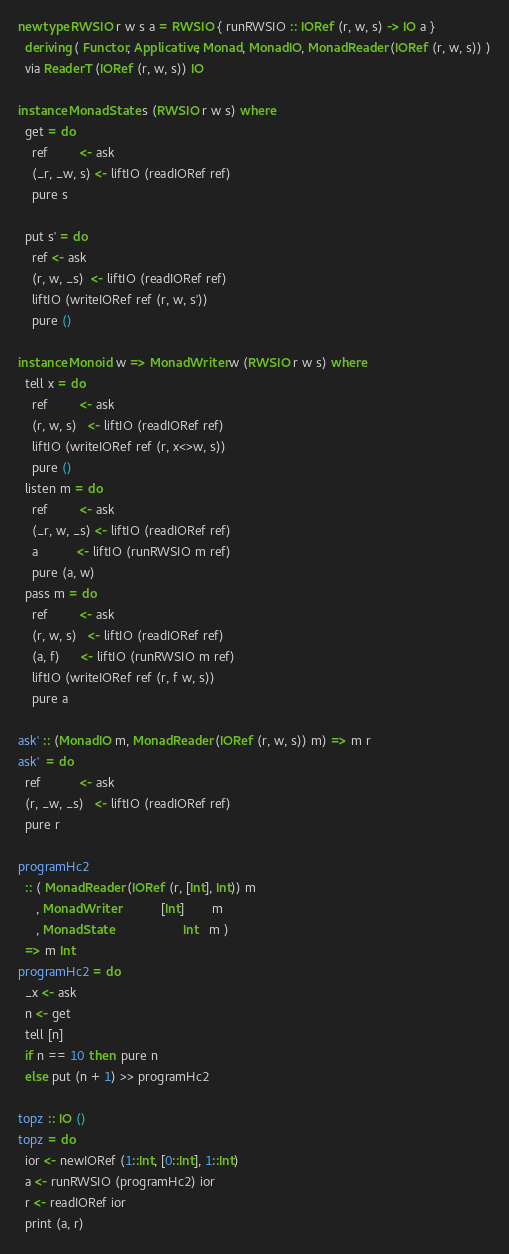<code> <loc_0><loc_0><loc_500><loc_500><_Haskell_>
newtype RWSIO r w s a = RWSIO { runRWSIO :: IORef (r, w, s) -> IO a }
  deriving ( Functor, Applicative, Monad, MonadIO, MonadReader (IORef (r, w, s)) )
  via ReaderT (IORef (r, w, s)) IO

instance MonadState s (RWSIO r w s) where
  get = do
    ref         <- ask
    (_r, _w, s) <- liftIO (readIORef ref)
    pure s

  put s' = do
    ref <- ask
    (r, w, _s)  <- liftIO (readIORef ref)
    liftIO (writeIORef ref (r, w, s'))
    pure ()

instance Monoid w => MonadWriter w (RWSIO r w s) where
  tell x = do
    ref         <- ask
    (r, w, s)   <- liftIO (readIORef ref)
    liftIO (writeIORef ref (r, x<>w, s))
    pure ()
  listen m = do
    ref         <- ask
    (_r, w, _s) <- liftIO (readIORef ref)
    a           <- liftIO (runRWSIO m ref)
    pure (a, w)
  pass m = do
    ref         <- ask
    (r, w, s)   <- liftIO (readIORef ref)
    (a, f)      <- liftIO (runRWSIO m ref)
    liftIO (writeIORef ref (r, f w, s))
    pure a

ask' :: (MonadIO m, MonadReader (IORef (r, w, s)) m) => m r
ask'  = do
  ref           <- ask
  (r, _w, _s)   <- liftIO (readIORef ref)
  pure r

programHc2
  :: ( MonadReader (IORef (r, [Int], Int)) m
     , MonadWriter            [Int]        m
     , MonadState                    Int   m )
  => m Int
programHc2 = do
  _x <- ask
  n <- get
  tell [n]
  if n == 10 then  pure n
  else put (n + 1) >> programHc2

topz :: IO ()
topz = do
  ior <- newIORef (1::Int, [0::Int], 1::Int)
  a <- runRWSIO (programHc2) ior
  r <- readIORef ior
  print (a, r)

</code> 